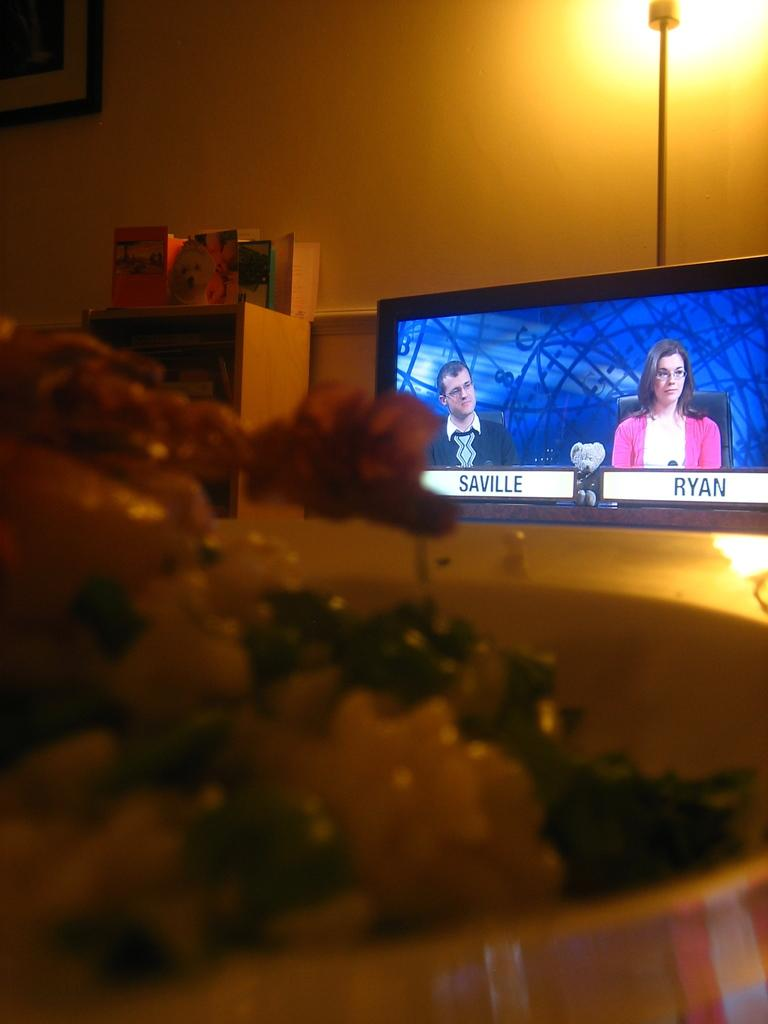What is on the plate that is visible in the image? There is food in a plate in the image. What can be seen in the background of the image? There is a television, lights, and books on a table in the background of the image. What is on the wall in the image? There is a frame on the wall in the image. What type of wax is being used to rub the spoon in the image? There is no wax or rubbing of a spoon present in the image. 